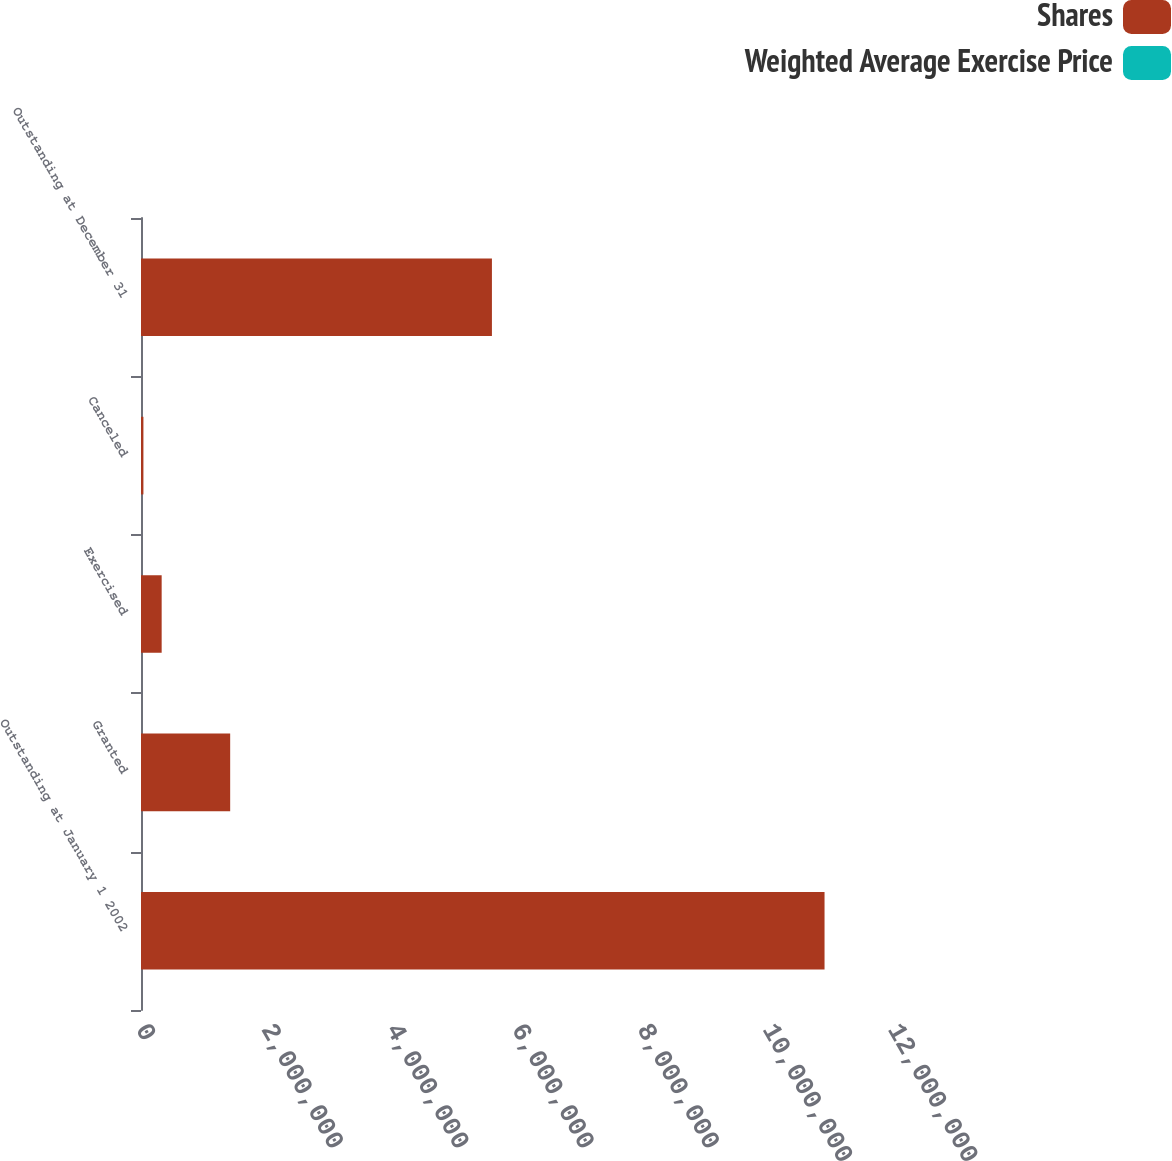Convert chart to OTSL. <chart><loc_0><loc_0><loc_500><loc_500><stacked_bar_chart><ecel><fcel>Outstanding at January 1 2002<fcel>Granted<fcel>Exercised<fcel>Canceled<fcel>Outstanding at December 31<nl><fcel>Shares<fcel>1.09076e+07<fcel>1.423e+06<fcel>329704<fcel>38509<fcel>5.59987e+06<nl><fcel>Weighted Average Exercise Price<fcel>34.28<fcel>37.73<fcel>30.28<fcel>37.13<fcel>38.08<nl></chart> 